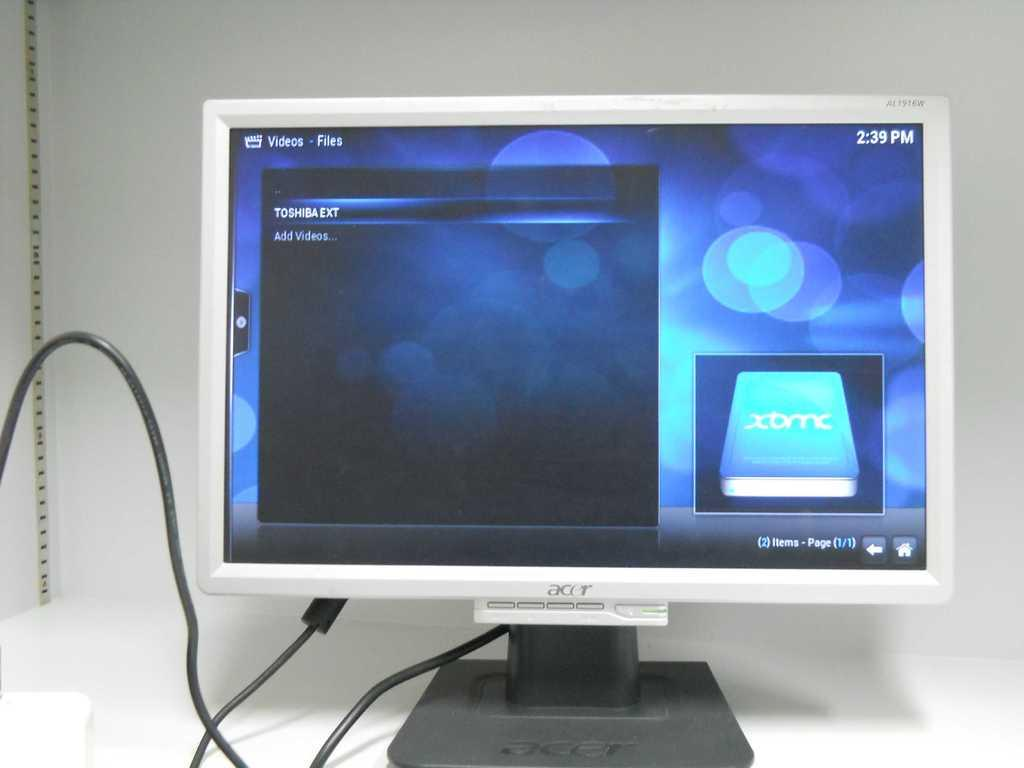<image>
Provide a brief description of the given image. A white acer computer monitor placed on a white surface. 